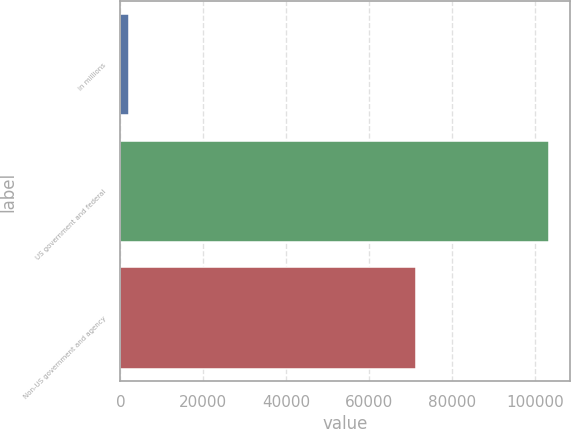<chart> <loc_0><loc_0><loc_500><loc_500><bar_chart><fcel>in millions<fcel>US government and federal<fcel>Non-US government and agency<nl><fcel>2014<fcel>103263<fcel>71302<nl></chart> 